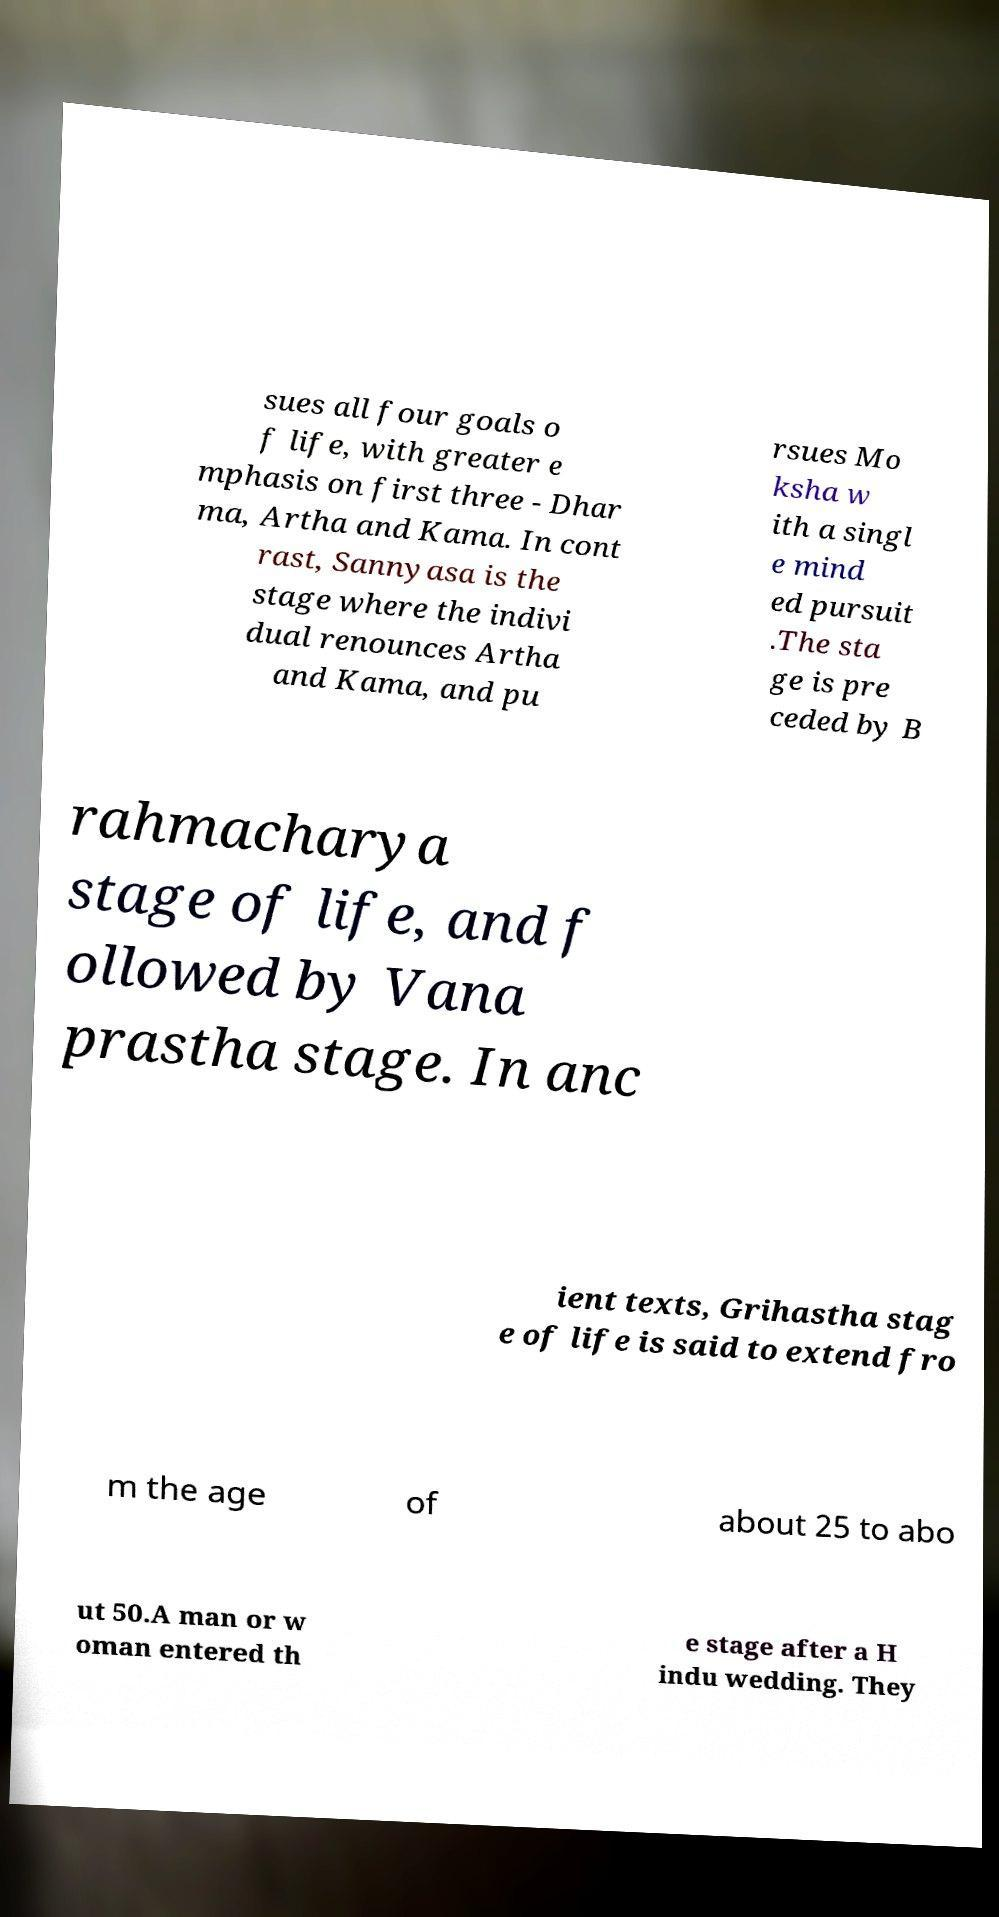Could you assist in decoding the text presented in this image and type it out clearly? sues all four goals o f life, with greater e mphasis on first three - Dhar ma, Artha and Kama. In cont rast, Sannyasa is the stage where the indivi dual renounces Artha and Kama, and pu rsues Mo ksha w ith a singl e mind ed pursuit .The sta ge is pre ceded by B rahmacharya stage of life, and f ollowed by Vana prastha stage. In anc ient texts, Grihastha stag e of life is said to extend fro m the age of about 25 to abo ut 50.A man or w oman entered th e stage after a H indu wedding. They 